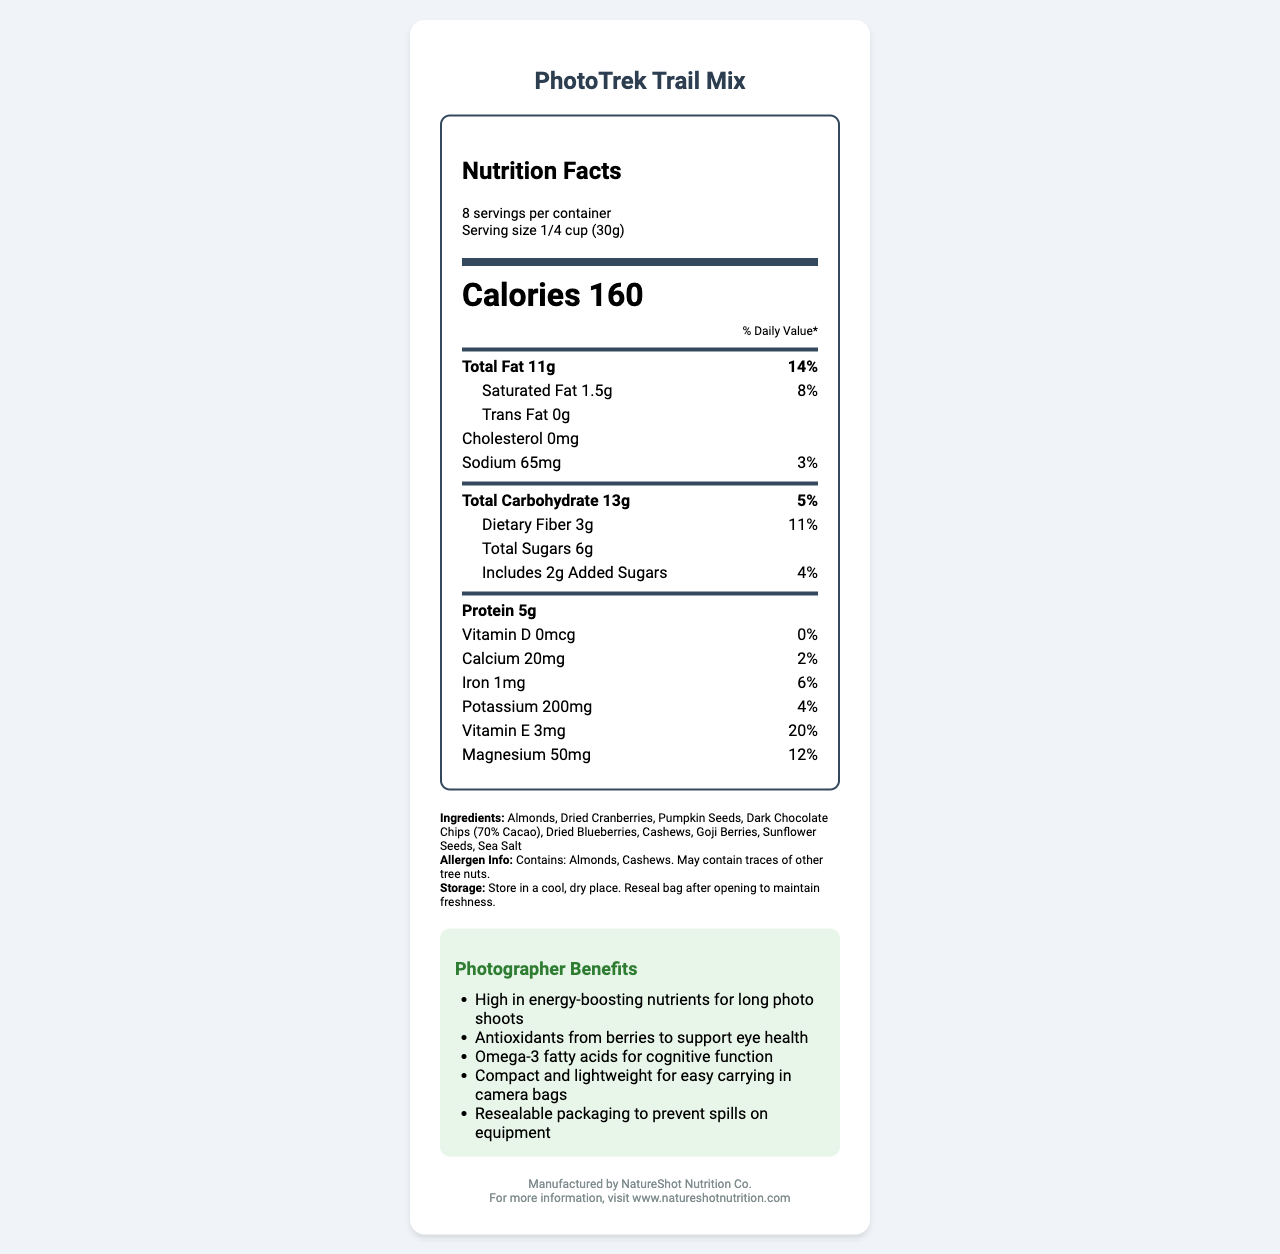what is the serving size? The serving size is stated in the serving information section just below the product name.
Answer: 1/4 cup (30g) how many calories are in one serving? The calorie count per serving is clearly indicated in bold, large font under the header "Calories".
Answer: 160 what is the total fat content in one serving? The total fat content is listed in the nutrient section, under the heading "Total Fat".
Answer: 11g how much dietary fiber does one serving contain? The dietary fiber amount is listed under the "Total Carbohydrate" section in the label.
Answer: 3g what percentage of the daily value of magnesium does one serving provide? The daily value percentage for magnesium is indicated in the nutrient section next to the amount of magnesium.
Answer: 12% which ingredient comes first in the ingredients list? The first ingredient in the list is "Almonds", which is found in the ingredients section.
Answer: Almonds how should the product be stored to maintain freshness? The storage instructions are provided under the ingredients and allergen information sections.
Answer: Store in a cool, dry place. Reseal bag after opening to maintain freshness. what is the sodium content in one serving? a) 55mg b) 60mg c) 65mg d) 70mg The sodium content is listed in the nutrient section as "Sodium 65mg".
Answer: c) 65mg which vitamin has the highest percentage daily value in this trail mix? a) Vitamin D b) Calcium c) Iron d) Vitamin E The document shows Vitamin E with a 20% daily value, which is the highest among the listed vitamins and minerals.
Answer: d) Vitamin E how much added sugar is in one serving? a) 1g b) 2g c) 3g d) 4g Under the sub-nutrient section for Total Sugars, the amount of added sugar is specified as 2g.
Answer: b) 2g does the trail mix contain any cholesterol? The cholesterol content in the mix is listed as "0mg", indicating that there is no cholesterol.
Answer: No are cashews a part of the ingredients? Cashews are listed as one of the ingredients in the trail mix.
Answer: Yes describe the main benefits of this trail mix for photographers. The benefits are specifically listed in the "Photographer Benefits" section, highlighting the energy, eye health, cognitive function, portability, and packaging features.
Answer: The trail mix is high in energy-boosting nutrients, antioxidants for eye health, omega-3 fatty acids for cognitive function, is compact for easy carrying, and has resealable packaging to prevent spills. who is the manufacturer of the PhotoTrek Trail Mix? The manufacturer's name is listed at the end of the document under the footer section.
Answer: NatureShot Nutrition Co. is the trail mix gluten-free? The document does not provide any information regarding gluten content or labeling it as gluten-free.
Answer: Not enough information what is the main idea of the document? The document is a detailed Nutrition Facts label and product description for PhotoTrek Trail Mix intended for nature photographers, emphasizing its nutrient contents, specific benefits, and practical features for the target audience.
Answer: The document provides comprehensive nutritional information about PhotoTrek Trail Mix, listing serving size, calorie count, and detailed nutrient breakdown, along with ingredients, allergen information, storage instructions, specific benefits for photographers, manufacturer details, and website for more information. 